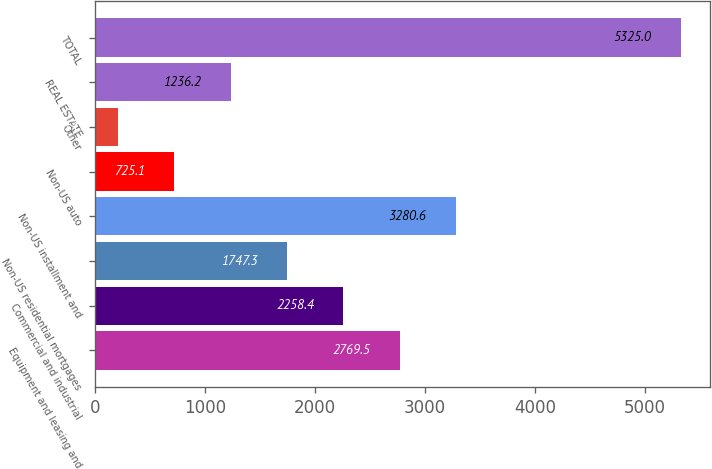Convert chart. <chart><loc_0><loc_0><loc_500><loc_500><bar_chart><fcel>Equipment and leasing and<fcel>Commercial and industrial<fcel>Non-US residential mortgages<fcel>Non-US installment and<fcel>Non-US auto<fcel>Other<fcel>REAL ESTATE<fcel>TOTAL<nl><fcel>2769.5<fcel>2258.4<fcel>1747.3<fcel>3280.6<fcel>725.1<fcel>214<fcel>1236.2<fcel>5325<nl></chart> 